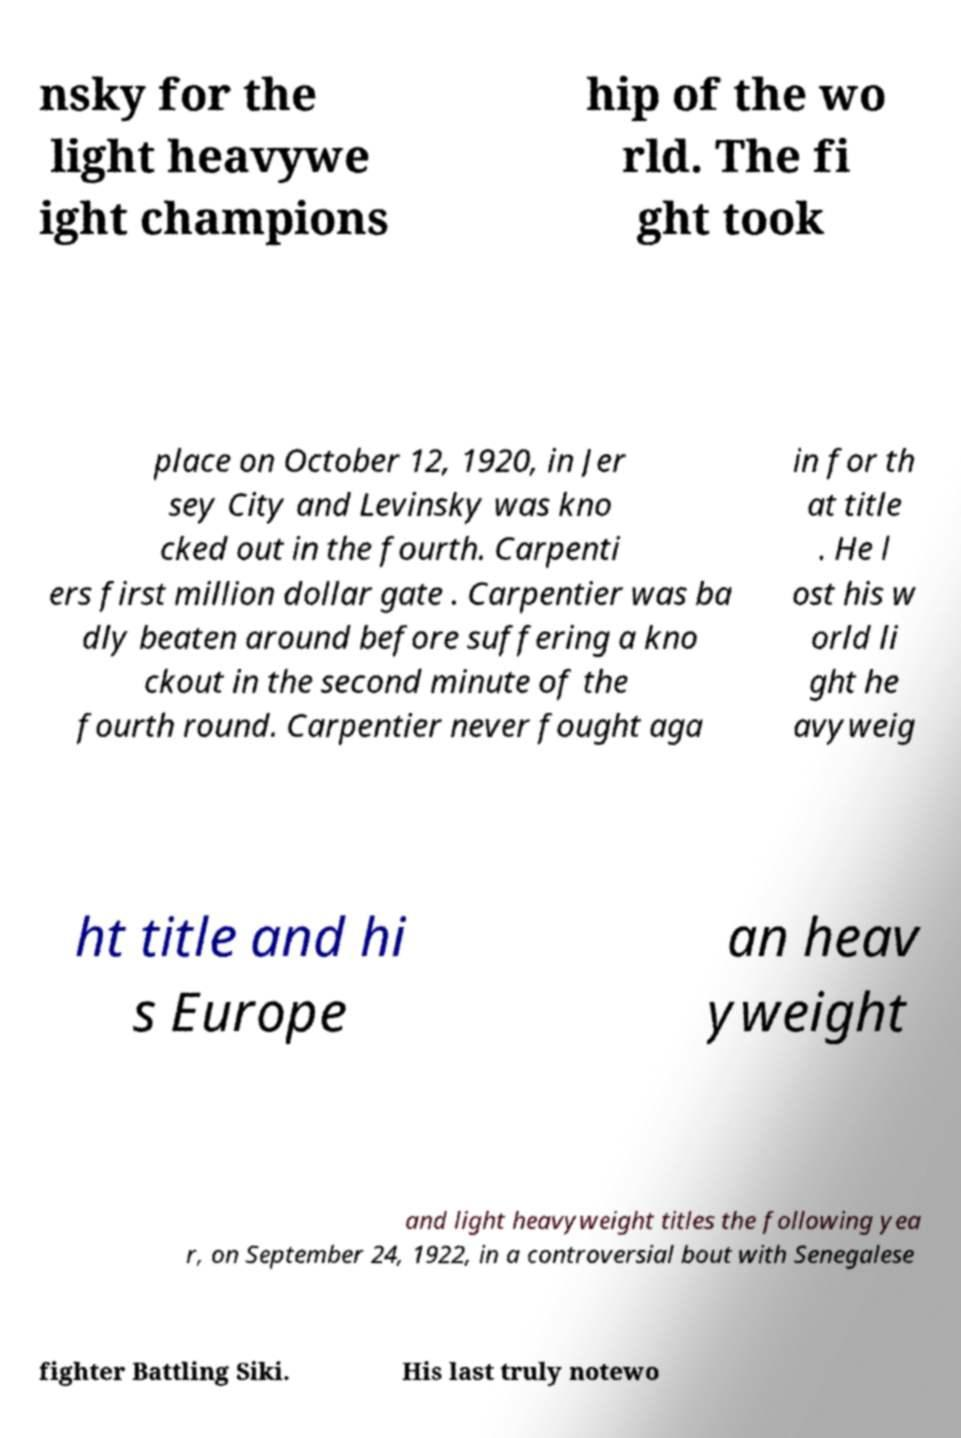Can you read and provide the text displayed in the image?This photo seems to have some interesting text. Can you extract and type it out for me? nsky for the light heavywe ight champions hip of the wo rld. The fi ght took place on October 12, 1920, in Jer sey City and Levinsky was kno cked out in the fourth. Carpenti ers first million dollar gate . Carpentier was ba dly beaten around before suffering a kno ckout in the second minute of the fourth round. Carpentier never fought aga in for th at title . He l ost his w orld li ght he avyweig ht title and hi s Europe an heav yweight and light heavyweight titles the following yea r, on September 24, 1922, in a controversial bout with Senegalese fighter Battling Siki. His last truly notewo 